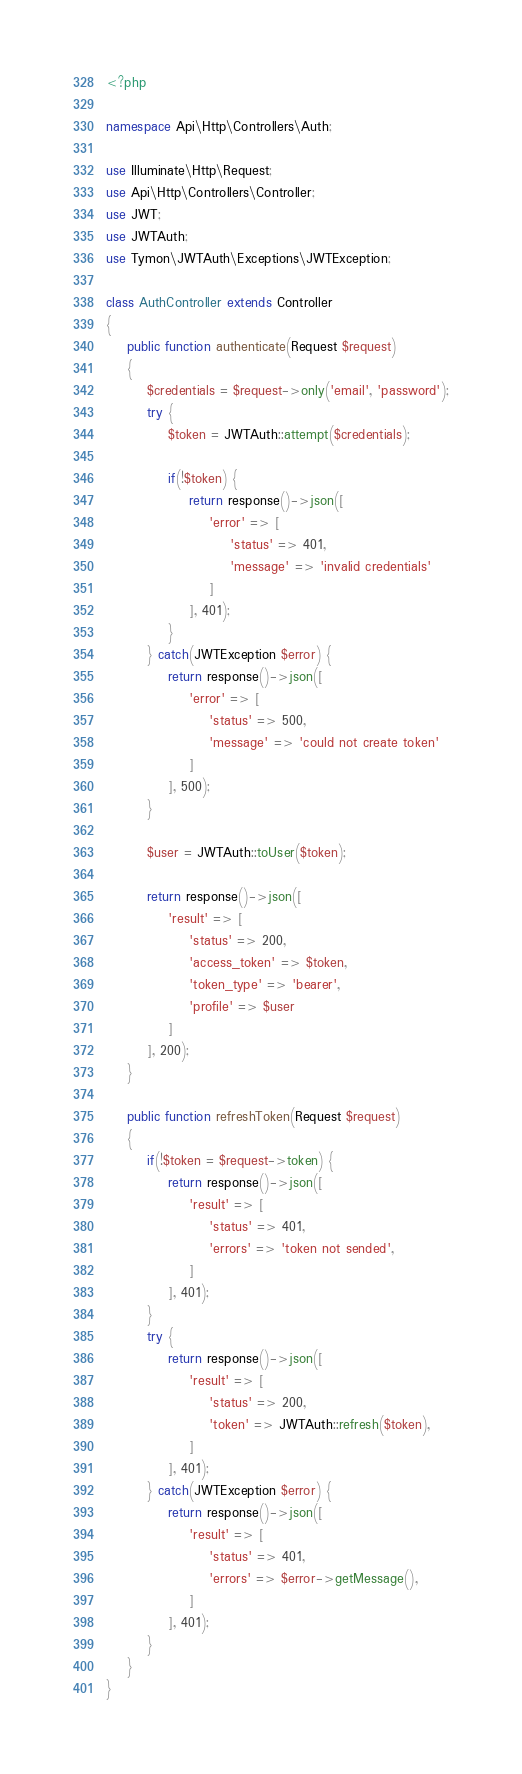Convert code to text. <code><loc_0><loc_0><loc_500><loc_500><_PHP_><?php

namespace Api\Http\Controllers\Auth;

use Illuminate\Http\Request;
use Api\Http\Controllers\Controller;
use JWT;
use JWTAuth;
use Tymon\JWTAuth\Exceptions\JWTException;

class AuthController extends Controller
{
    public function authenticate(Request $request)
    {
    	$credentials = $request->only('email', 'password');
    	try {
            $token = JWTAuth::attempt($credentials);

            if(!$token) {
                return response()->json([
                    'error' => [
                        'status' => 401,
                        'message' => 'invalid credentials'
                    ]
                ], 401);
            }
    	} catch(JWTException $error) {
    		return response()->json([
    		    'error' => [
                    'status' => 500,
    		        'message' => 'could not create token'
                ]
            ], 500);
    	}

        $user = JWTAuth::toUser($token);

    	return response()->json([
    	    'result' => [
                'status' => 200,
                'access_token' => $token,
                'token_type' => 'bearer',
                'profile' => $user
            ]
        ], 200);
    }

    public function refreshToken(Request $request)
    {
        if(!$token = $request->token) {
            return response()->json([
                'result' => [
                    'status' => 401,
                    'errors' => 'token not sended',
                ]
            ], 401);
        }
        try {
            return response()->json([
                'result' => [
                    'status' => 200,
                    'token' => JWTAuth::refresh($token),
                ]
            ], 401);
        } catch(JWTException $error) {
            return response()->json([
                'result' => [
                    'status' => 401,
                    'errors' => $error->getMessage(),
                ]
            ], 401);
        }
    }
}
</code> 